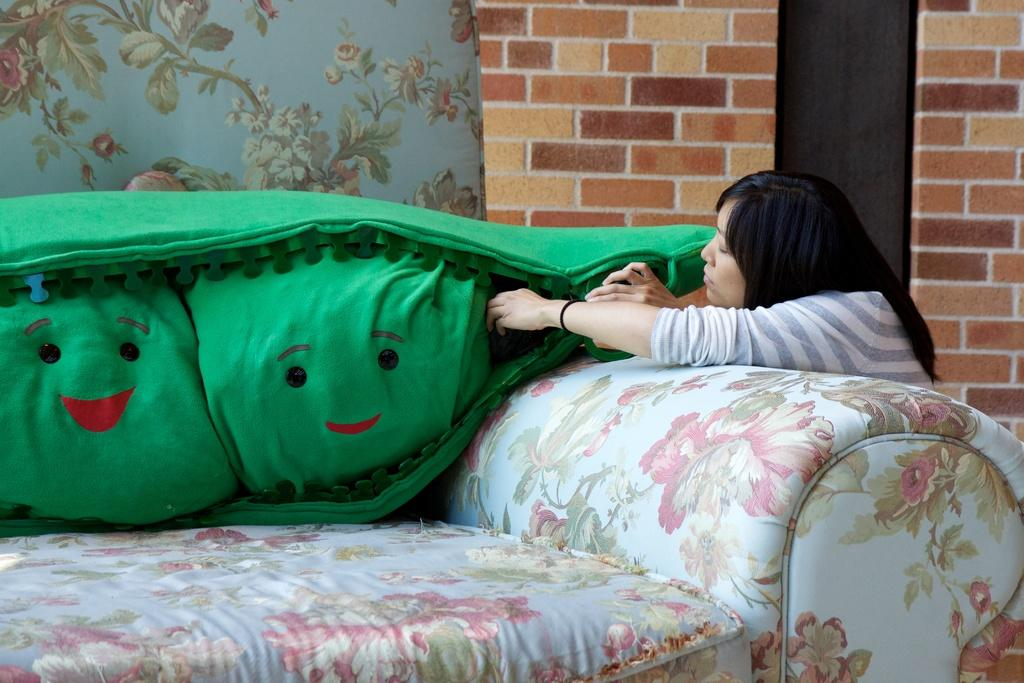Who is present on the right side of the image? There is a woman on the right side of the image. What piece of furniture is located on the left side of the image? There is a sofa on the left side of the image. What can be seen in the background of the image? There is a wall in the background of the image. What type of silk material is draped over the woman's shoulder in the image? There is no silk material present in the image. Can you describe the woman's reaction to the kiss in the image? There is no kiss present in the image. What causes the woman to laugh in the image? There is no laughter depicted in the image. 